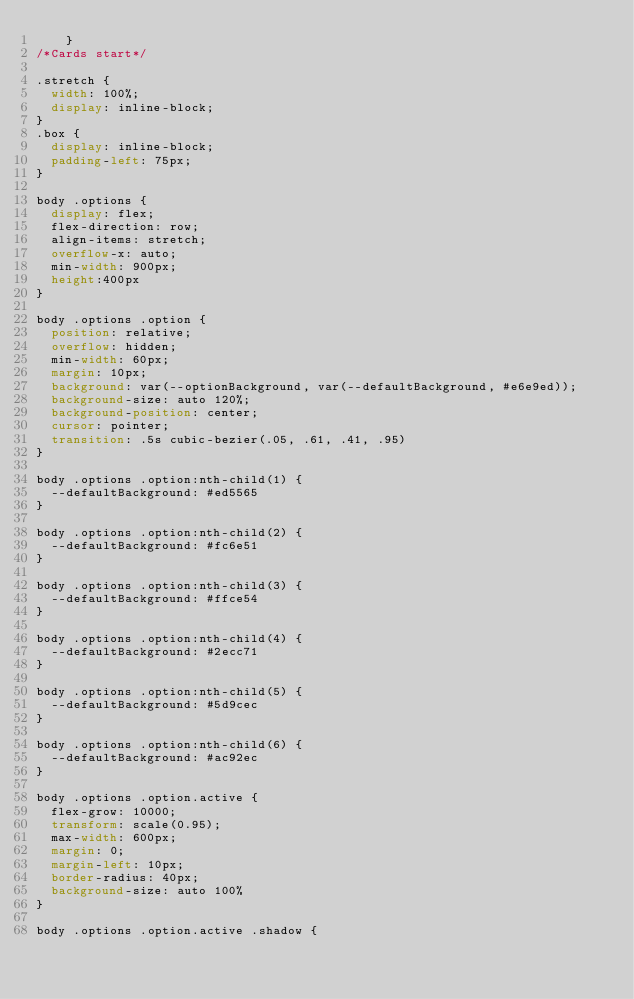<code> <loc_0><loc_0><loc_500><loc_500><_CSS_>    }
/*Cards start*/

.stretch {
	width: 100%;
	display: inline-block;
}
.box {
	display: inline-block;
	padding-left: 75px;
}

body .options {
	display: flex;
	flex-direction: row;
	align-items: stretch;
	overflow-x: auto;
	min-width: 900px;
	height:400px
}

body .options .option {
	position: relative;
	overflow: hidden;
	min-width: 60px;
	margin: 10px;
	background: var(--optionBackground, var(--defaultBackground, #e6e9ed));
	background-size: auto 120%;
	background-position: center;
	cursor: pointer;
	transition: .5s cubic-bezier(.05, .61, .41, .95)
}

body .options .option:nth-child(1) {
	--defaultBackground: #ed5565
}

body .options .option:nth-child(2) {
	--defaultBackground: #fc6e51
}

body .options .option:nth-child(3) {
	--defaultBackground: #ffce54
}

body .options .option:nth-child(4) {
	--defaultBackground: #2ecc71
}

body .options .option:nth-child(5) {
	--defaultBackground: #5d9cec
}

body .options .option:nth-child(6) {
	--defaultBackground: #ac92ec
}

body .options .option.active {
	flex-grow: 10000;
	transform: scale(0.95);
	max-width: 600px;
	margin: 0;
	margin-left: 10px;
	border-radius: 40px;
	background-size: auto 100%
}

body .options .option.active .shadow {</code> 